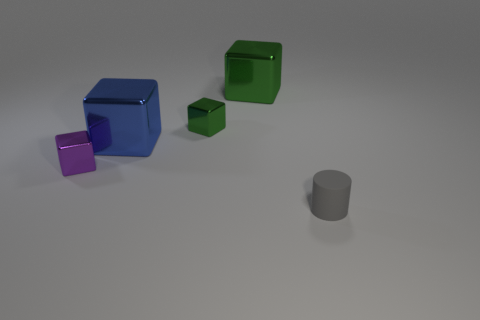Subtract all purple blocks. How many blocks are left? 3 Subtract all cyan blocks. Subtract all gray cylinders. How many blocks are left? 4 Add 5 big blocks. How many objects exist? 10 Subtract all blocks. How many objects are left? 1 Add 1 matte objects. How many matte objects are left? 2 Add 5 tiny purple shiny things. How many tiny purple shiny things exist? 6 Subtract 1 green blocks. How many objects are left? 4 Subtract all tiny green matte cylinders. Subtract all tiny metallic blocks. How many objects are left? 3 